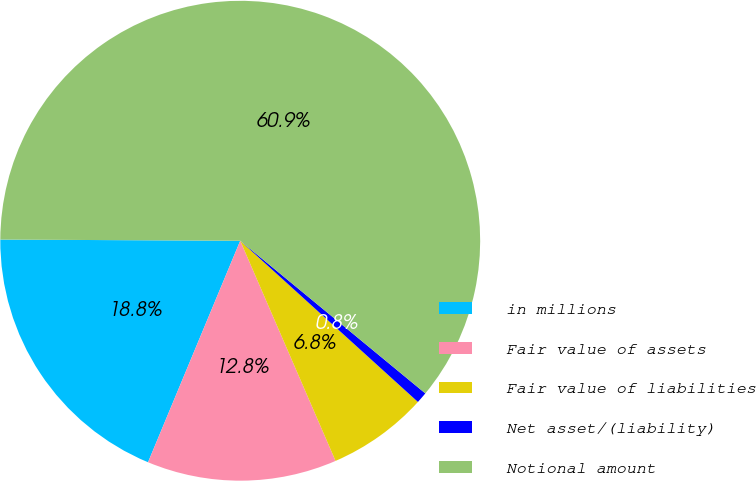Convert chart to OTSL. <chart><loc_0><loc_0><loc_500><loc_500><pie_chart><fcel>in millions<fcel>Fair value of assets<fcel>Fair value of liabilities<fcel>Net asset/(liability)<fcel>Notional amount<nl><fcel>18.8%<fcel>12.78%<fcel>6.77%<fcel>0.75%<fcel>60.9%<nl></chart> 